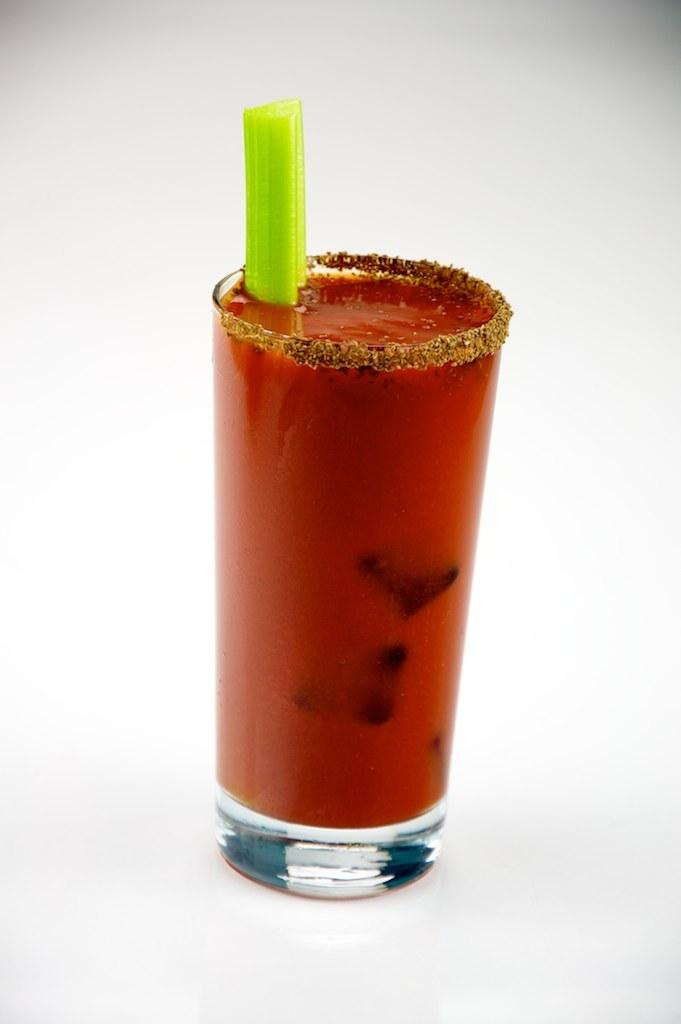What object is visible in the image that is typically used for holding liquids? There is a glass in the image. Where is the glass located in the image? The glass is on a table. What type of clouds can be seen in the image? There are no clouds present in the image; it only features a glass on a table. 